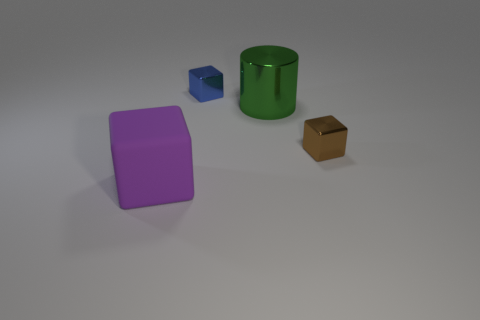Is there any other thing that has the same material as the tiny blue block?
Provide a succinct answer. Yes. There is a small metallic thing that is behind the brown metallic block in front of the large thing right of the rubber cube; what shape is it?
Provide a succinct answer. Cube. What number of other things are there of the same shape as the tiny brown object?
Provide a short and direct response. 2. There is a thing that is the same size as the purple block; what color is it?
Keep it short and to the point. Green. What number of spheres are either large metal things or purple things?
Ensure brevity in your answer.  0. How many cylinders are there?
Your answer should be compact. 1. Is the shape of the large purple object the same as the big thing behind the brown object?
Make the answer very short. No. How many objects are either cyan rubber objects or blue metallic cubes?
Provide a short and direct response. 1. What is the shape of the small object that is in front of the big thing that is on the right side of the large purple block?
Provide a short and direct response. Cube. Is the shape of the large object left of the shiny cylinder the same as  the tiny brown thing?
Give a very brief answer. Yes. 